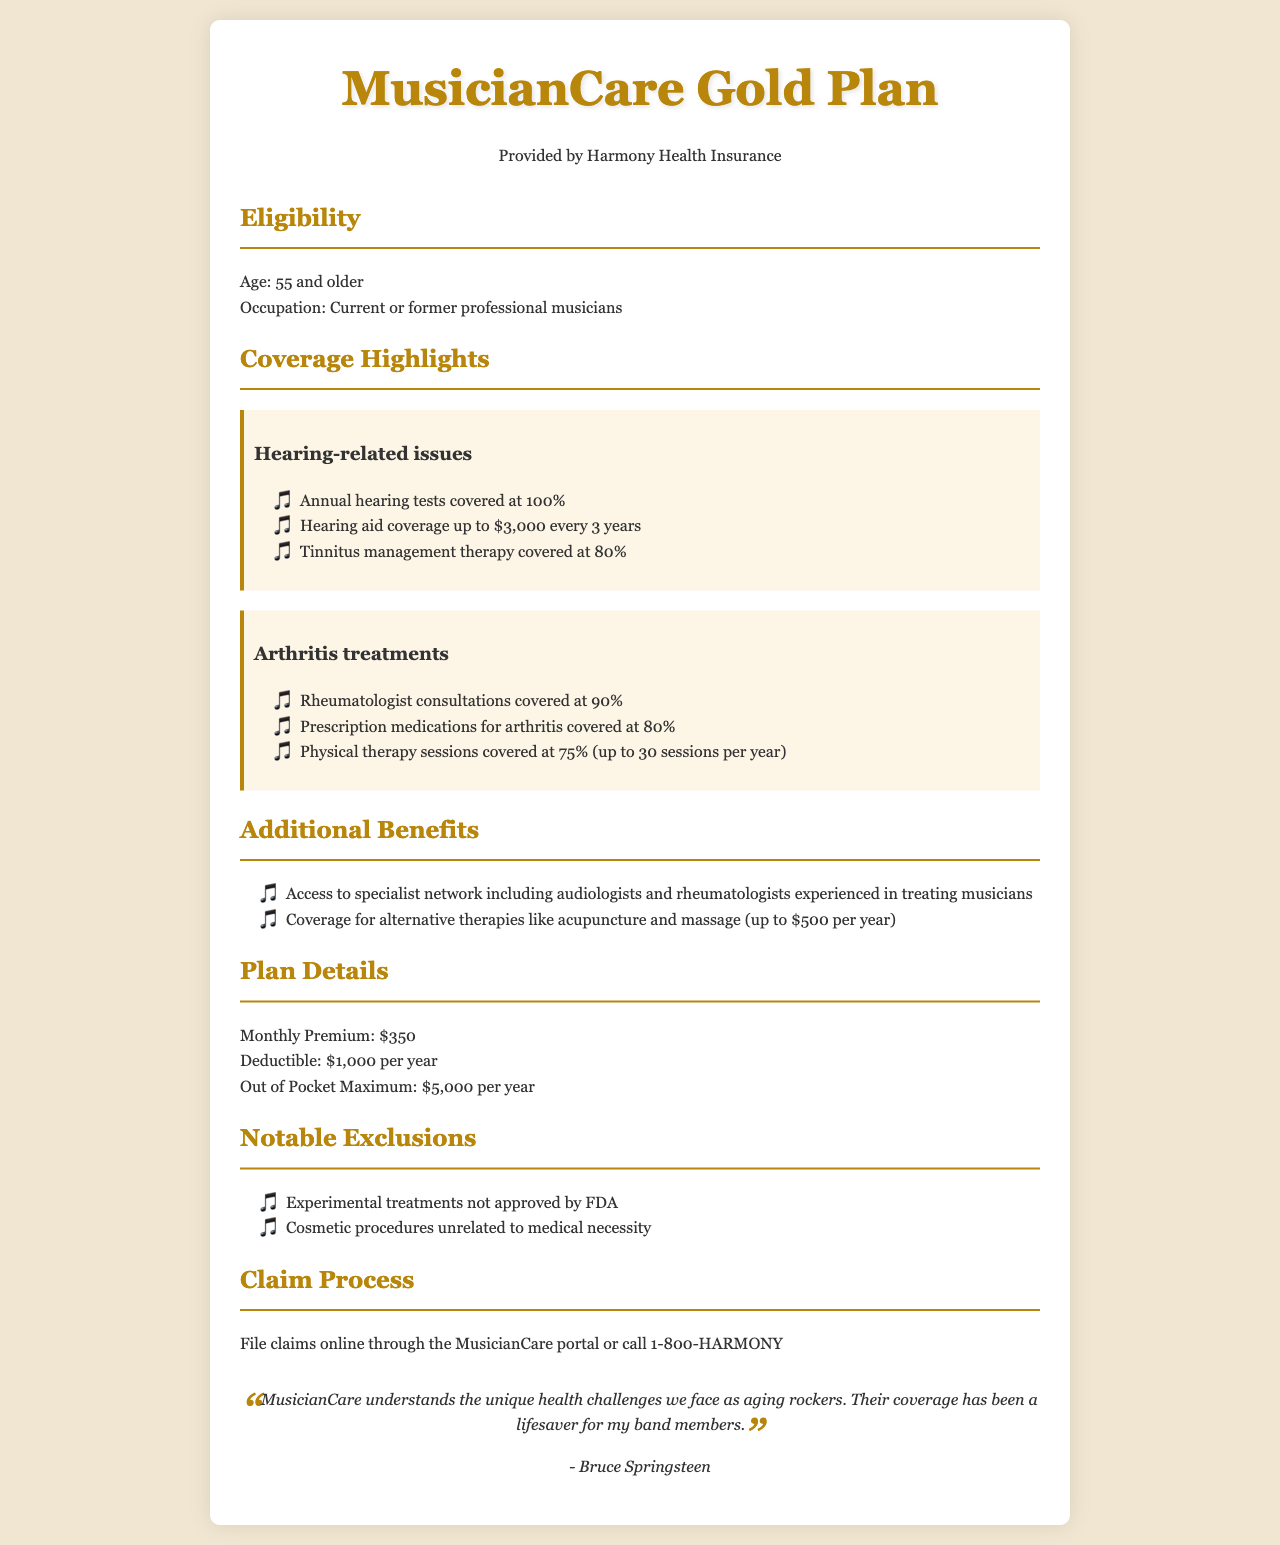What is the maximum coverage for hearing aids? The document states that hearing aid coverage is provided up to $3,000 every 3 years.
Answer: $3,000 What age must a musician be to be eligible for this plan? The eligibility section indicates that musicians must be age 55 and older.
Answer: 55 What percentage of prescription medications for arthritis is covered? The document specifies that prescription medications for arthritis are covered at 80%.
Answer: 80% How many physical therapy sessions are covered per year? The plan details mention that physical therapy sessions are covered up to 30 sessions per year.
Answer: 30 sessions What is the monthly premium for the MusicianCare Gold Plan? Under plan details, it is stated that the monthly premium is $350.
Answer: $350 What is the out-of-pocket maximum per year? The document indicates that the out-of-pocket maximum is $5,000 per year.
Answer: $5,000 Are alternative therapies covered under this health insurance? The document mentions that coverage for alternative therapies like acupuncture and massage is included, up to $500 per year.
Answer: Yes, up to $500 Who is the testimonial attributed to in the document? The testimonial section quotes Bruce Springsteen, highlighting the positive experiences of aging musicians.
Answer: Bruce Springsteen What kind of specialists does the plan provide access to? The document states that there is access to a specialist network including audiologists and rheumatologists.
Answer: Audiologists and rheumatologists 